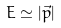<formula> <loc_0><loc_0><loc_500><loc_500>E \simeq | \vec { p } |</formula> 